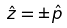Convert formula to latex. <formula><loc_0><loc_0><loc_500><loc_500>\hat { z } = \pm \hat { p }</formula> 